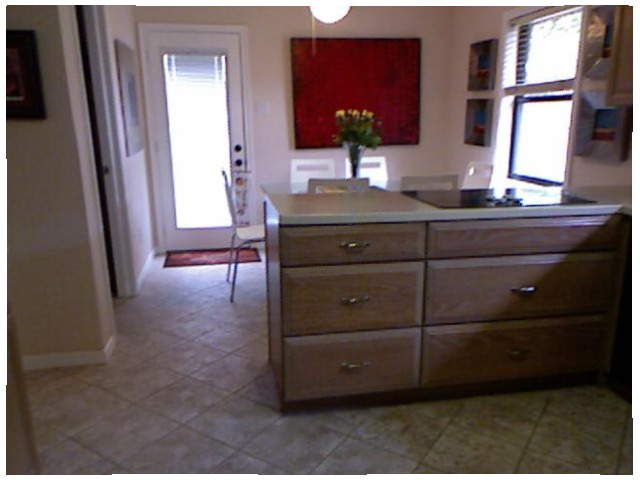<image>
Is there a flattop stove under the drawer? No. The flattop stove is not positioned under the drawer. The vertical relationship between these objects is different. Where is the flower in relation to the counter? Is it on the counter? No. The flower is not positioned on the counter. They may be near each other, but the flower is not supported by or resting on top of the counter. Is the door behind the chair? Yes. From this viewpoint, the door is positioned behind the chair, with the chair partially or fully occluding the door. 